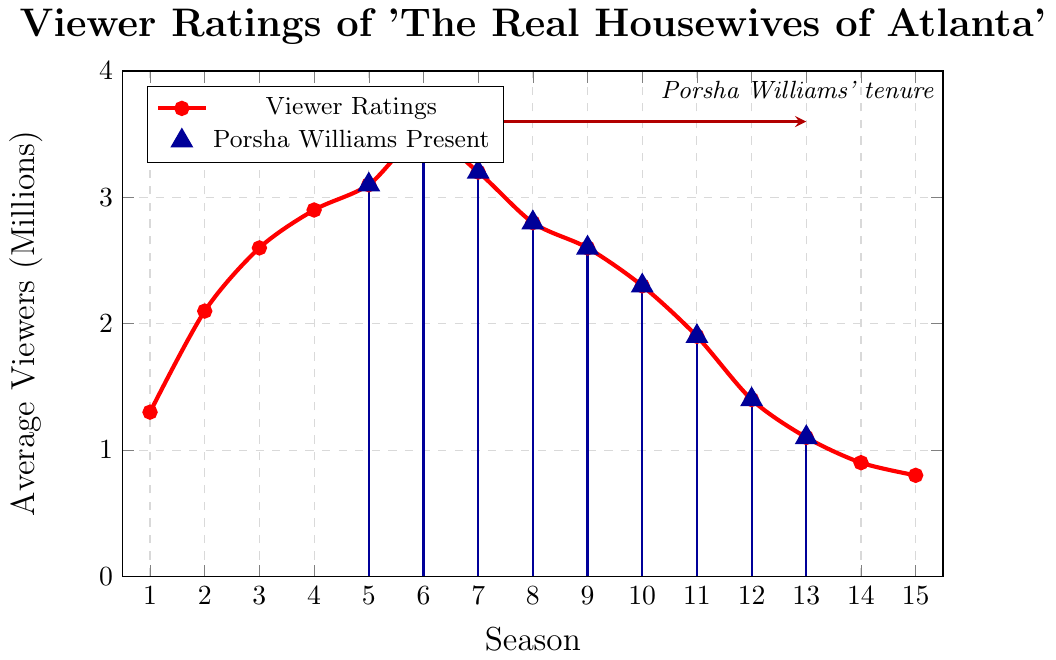What is the average number of viewers for Season 5? Look for Season 5 on the x-axis and read the corresponding Average Viewers value on the y-axis.
Answer: 3.1 million Which season had the highest average number of viewers? Identify the peak of the 'Viewer Ratings' line on the chart. The highest point is at Season 6 with 3.5 million viewers.
Answer: Season 6 How did viewer ratings change after Porsha Williams joined the show? Porsha Williams joined in Season 5. After this point, viewer ratings initially increased, peaking at Season 6 with 3.5 million viewers, then started to decline gradually from Season 7 onwards.
Answer: Initially increased, then declined Compare the average number of viewers in the seasons before and after Porsha Williams joined. Calculate the average for Seasons 1-4 (1.3 + 2.1 + 2.6 + 2.9 = 8.9/4 = 2.225 million). Calculate the average for Seasons 5-13 (3.1 + 3.5 + 3.2 + 2.8 + 2.6 + 2.3 + 1.9 + 1.4 + 1.1 = 21.9/9 = 2.433 million). Compare these two averages.
Answer: Before: 2.225 million, After: 2.433 million Which season saw the greatest drop in average viewers compared to its previous season? Calculate the differences between consecutive seasons: 
Season 6 to 7 (3.5 - 3.2 = 0.3), 
Season 7 to 8 (3.2 - 2.8 = 0.4), 
Season 8 to 9 (2.8 - 2.6 = 0.2), 
Season 9 to 10 (2.6 - 2.3 = 0.3), 
Season 10 to 11 (2.3 - 1.9 = 0.4), 
Season 11 to 12 (1.9 - 1.4 = 0.5), 
Season 12 to 13 (1.4 - 1.1 = 0.3). 
The greatest drop is from Season 11 to 12 with a drop of 0.5 million viewers.
Answer: Between Seasons 11 and 12 What is the overall trend in viewer ratings from Season 1 to Season 15? Observe the 'Viewer Ratings' line: it starts low, gradually increases achieving a peak at Season 6, then follows a declining trend to Season 15.
Answer: Increasing trend till Season 6, then declining How many seasons did Porsha Williams appear on the show? The blue triangles represent the seasons with Porsha Williams' presence. Count the triangles from Season 5 to Season 13.
Answer: 9 seasons What is the difference in average viewers between the highest-rated season and the lowest-rated season? Identify the highest-rated season (Season 6: 3.5 million) and the lowest-rated season (Season 15: 0.8 million). Calculate the difference (3.5 - 0.8 = 2.7).
Answer: 2.7 million During which seasons did viewer ratings decline while Porsha Williams was present? Identify the seasons with Porsha Williams and compare consecutive viewers' ratings: Decline from Season 6 to 7 (3.5 to 3.2), from 7 to 8 (3.2 to 2.8), from 8 to 9 (2.8 to 2.6), from 9 to 10 (2.6 to 2.3), from 10 to 11 (2.3 to 1.9), from 11 to 12 (1.9 to 1.4), from 12 to 13 (1.4 to 1.1).
Answer: Seasons 6-7, 7-8, 8-9, 9-10, 10-11, 11-12, 12-13 